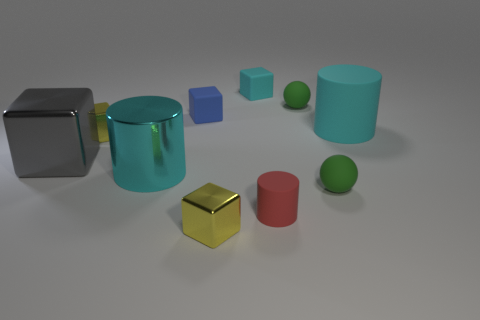Subtract all big gray shiny cubes. How many cubes are left? 4 Subtract all blue blocks. How many blocks are left? 4 Subtract all green cubes. Subtract all yellow balls. How many cubes are left? 5 Subtract all balls. How many objects are left? 8 Add 4 large metal things. How many large metal things are left? 6 Add 4 small brown matte cubes. How many small brown matte cubes exist? 4 Subtract 2 cyan cylinders. How many objects are left? 8 Subtract all big gray metal cylinders. Subtract all red matte cylinders. How many objects are left? 9 